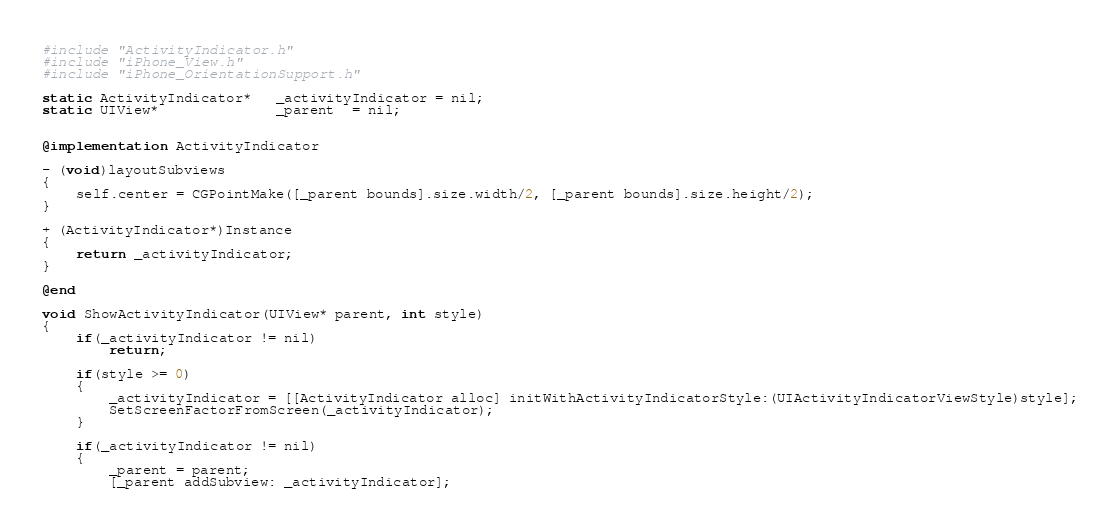<code> <loc_0><loc_0><loc_500><loc_500><_ObjectiveC_>
#include "ActivityIndicator.h"
#include "iPhone_View.h"
#include "iPhone_OrientationSupport.h"

static ActivityIndicator*   _activityIndicator = nil;
static UIView*              _parent  = nil;


@implementation ActivityIndicator

- (void)layoutSubviews
{
    self.center = CGPointMake([_parent bounds].size.width/2, [_parent bounds].size.height/2);
}

+ (ActivityIndicator*)Instance
{
    return _activityIndicator;
}

@end

void ShowActivityIndicator(UIView* parent, int style)
{
    if(_activityIndicator != nil)
        return;

    if(style >= 0)
    {
        _activityIndicator = [[ActivityIndicator alloc] initWithActivityIndicatorStyle:(UIActivityIndicatorViewStyle)style];
        SetScreenFactorFromScreen(_activityIndicator);
    }

    if(_activityIndicator != nil)
    {
        _parent = parent;
        [_parent addSubview: _activityIndicator];</code> 